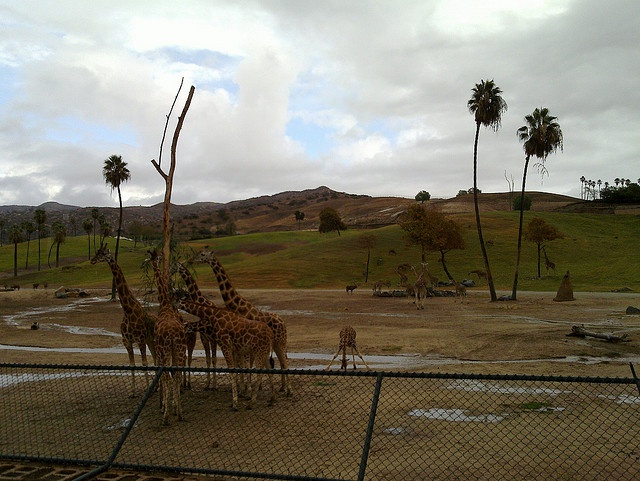Describe the objects in this image and their specific colors. I can see giraffe in white, black, maroon, and gray tones, giraffe in white, black, maroon, and gray tones, giraffe in white, black, maroon, and gray tones, giraffe in white, black, maroon, and gray tones, and giraffe in lightgray, black, and gray tones in this image. 